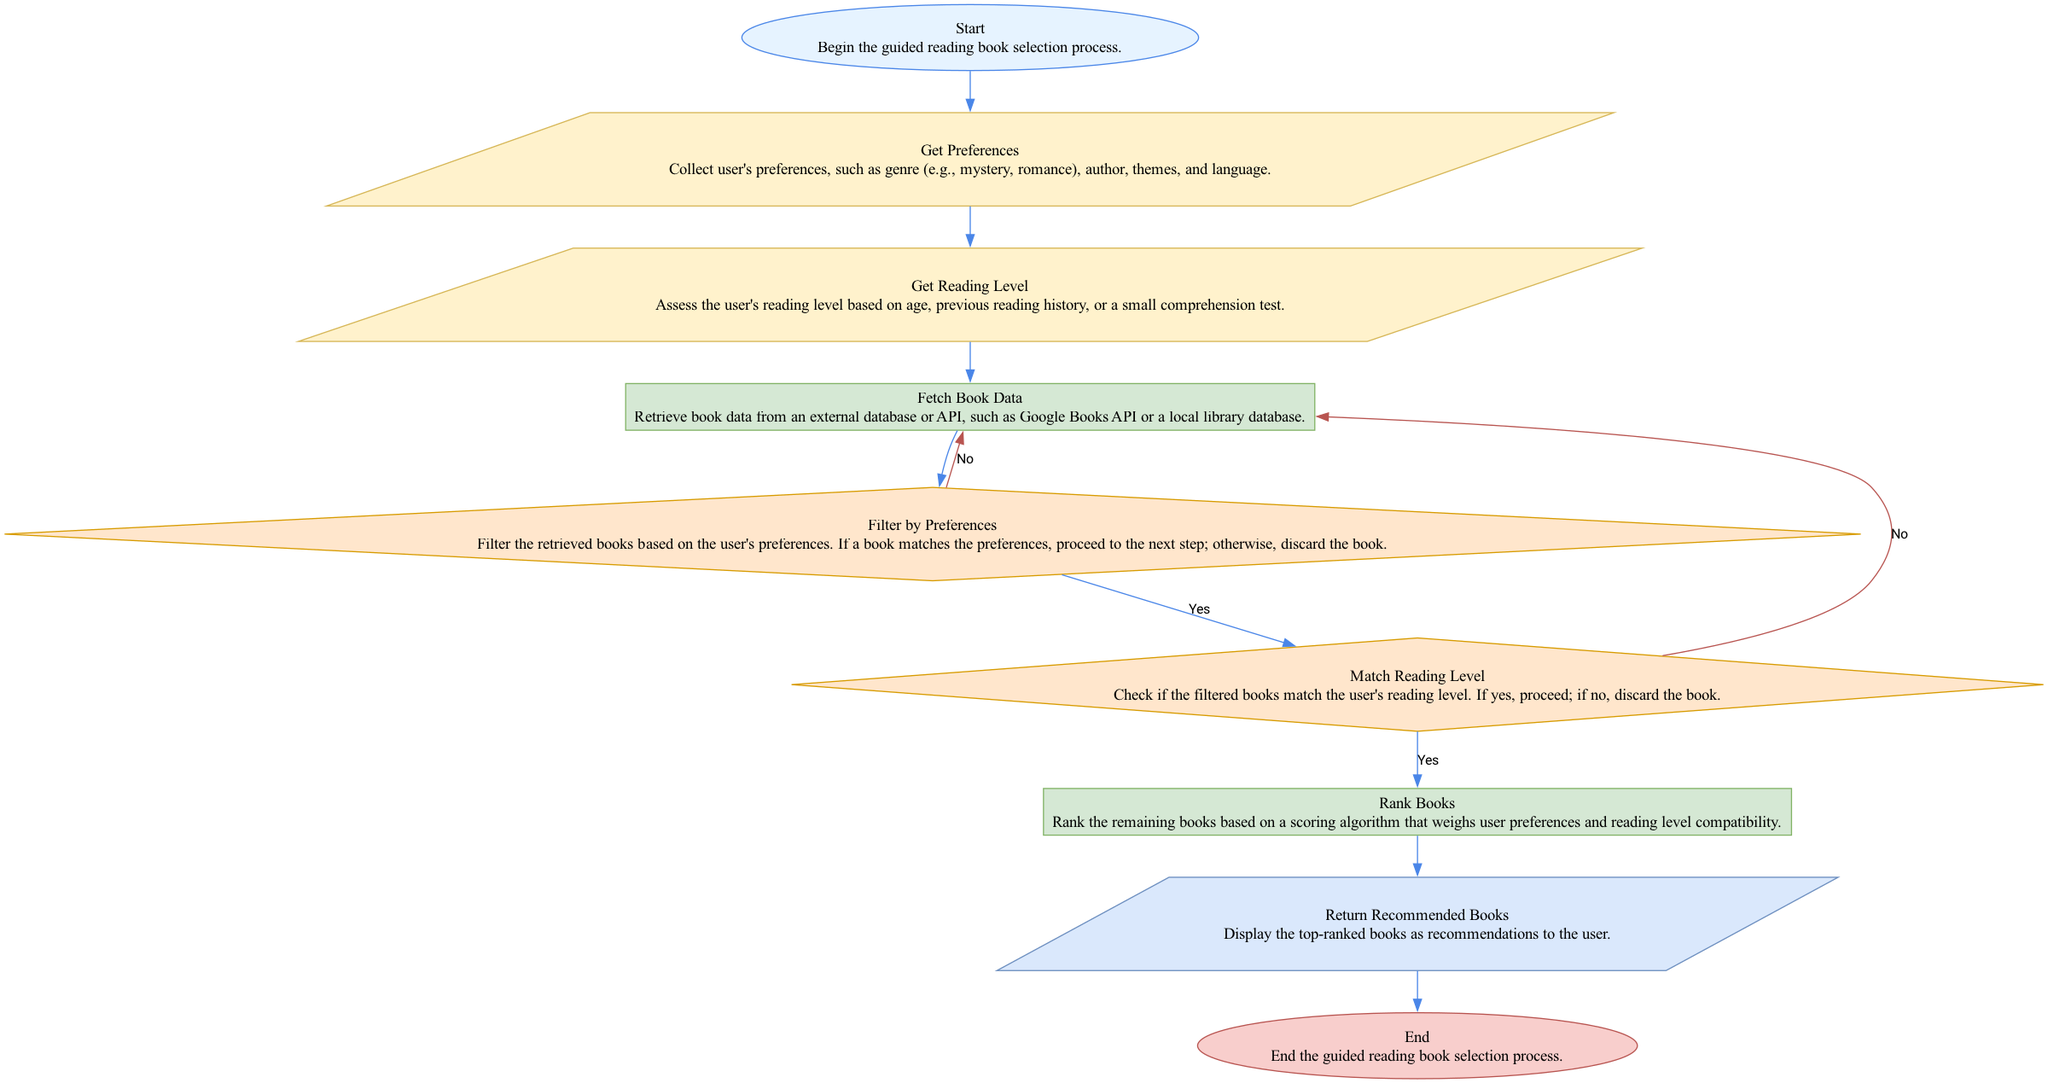What is the first step in the flowchart? The first step is labeled "Start" and indicates the beginning of the guided reading book selection process.
Answer: Start How many decision nodes are present in the diagram? There are two decision nodes: "Filter by Preferences" and "Match Reading Level".
Answer: 2 What does the "Fetch Book Data" node do? This node retrieves book data from an external database or API, such as Google Books API or a local library database.
Answer: Retrieve book data What happens if a book does not match the user's preferences? If a book does not match the user's preferences, it is discarded according to the "Filter by Preferences" decision node.
Answer: Discard the book What is the outcome of the ranking process? The ranking process leads to the "Return Recommended Books" output node, which displays the top-ranked books to the user.
Answer: Return Recommended Books Which node comes after the "Get Reading Level"? The node that comes after "Get Reading Level" is "Fetch Book Data".
Answer: Fetch Book Data What does the user input at the beginning of the process? At the beginning of the process, the user inputs their preferences regarding genre, author, themes, and language.
Answer: User's preferences How does the flowchart indicate the end of the process? The flowchart indicates the end of the process with an "End" node, which signifies the conclusion of the guided reading book selection process.
Answer: End What action is taken if the filtered books do not match the user's reading level? If the filtered books do not match the user's reading level, the books are discarded as indicated by the "Match Reading Level" decision node.
Answer: Discard the book What color is the "Get Preferences" node? The "Get Preferences" node is colored with a fill of #FFF2CC, which indicates it is an input node.
Answer: #FFF2CC 